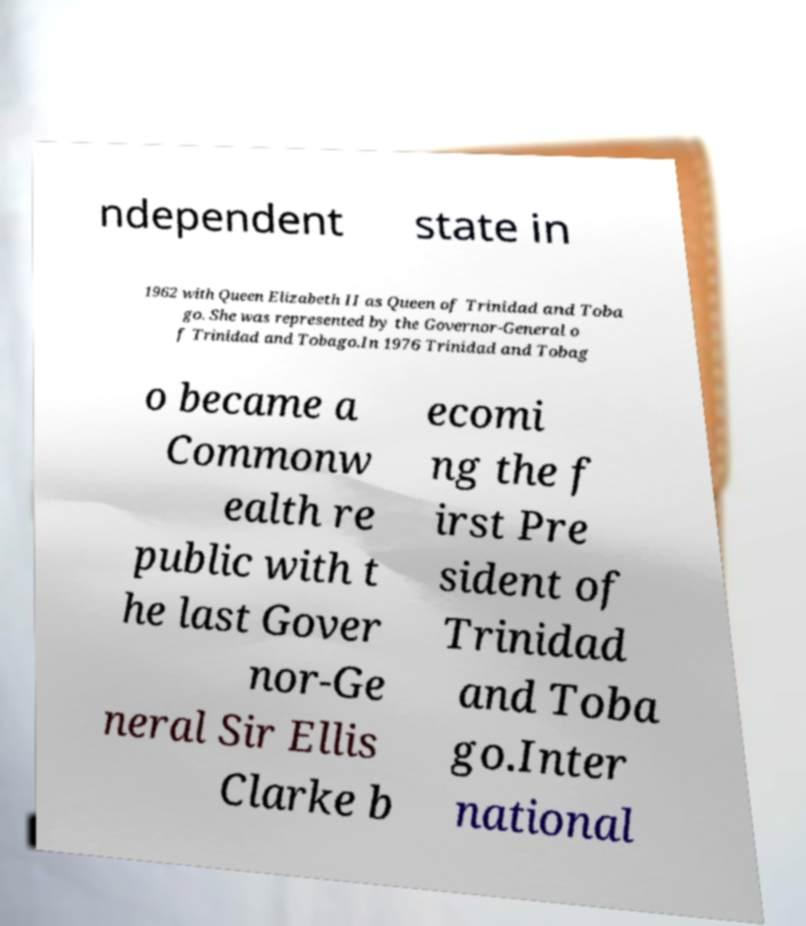For documentation purposes, I need the text within this image transcribed. Could you provide that? ndependent state in 1962 with Queen Elizabeth II as Queen of Trinidad and Toba go. She was represented by the Governor-General o f Trinidad and Tobago.In 1976 Trinidad and Tobag o became a Commonw ealth re public with t he last Gover nor-Ge neral Sir Ellis Clarke b ecomi ng the f irst Pre sident of Trinidad and Toba go.Inter national 